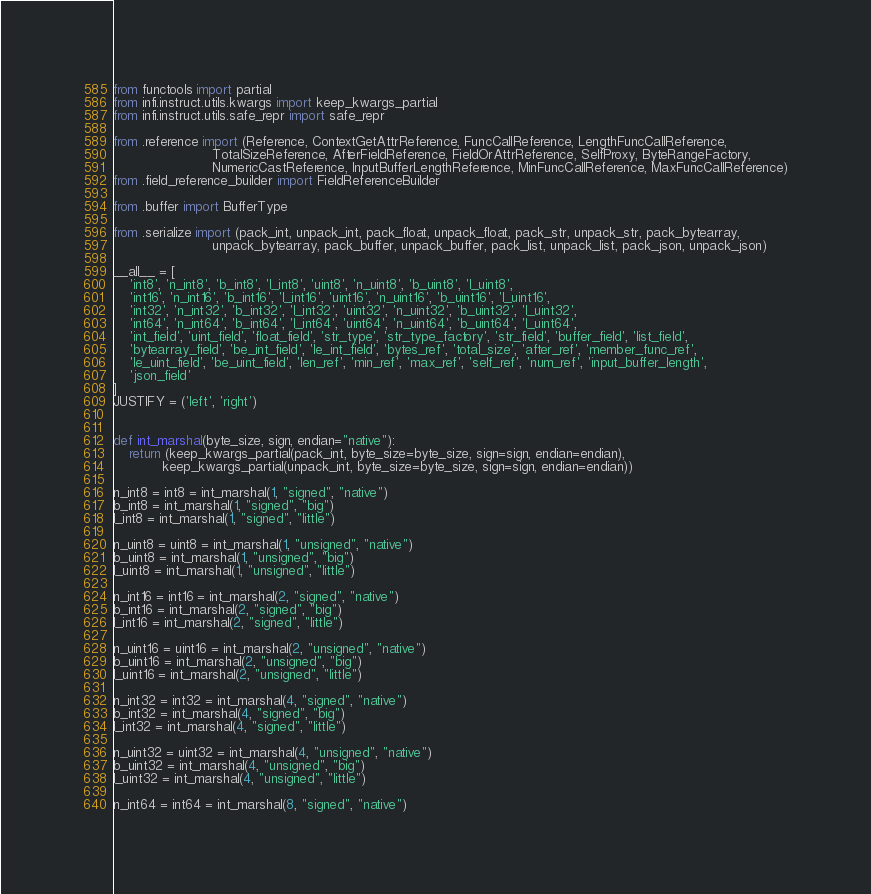<code> <loc_0><loc_0><loc_500><loc_500><_Python_>from functools import partial
from infi.instruct.utils.kwargs import keep_kwargs_partial
from infi.instruct.utils.safe_repr import safe_repr

from .reference import (Reference, ContextGetAttrReference, FuncCallReference, LengthFuncCallReference,
                        TotalSizeReference, AfterFieldReference, FieldOrAttrReference, SelfProxy, ByteRangeFactory,
                        NumericCastReference, InputBufferLengthReference, MinFuncCallReference, MaxFuncCallReference)
from .field_reference_builder import FieldReferenceBuilder

from .buffer import BufferType

from .serialize import (pack_int, unpack_int, pack_float, unpack_float, pack_str, unpack_str, pack_bytearray,
                        unpack_bytearray, pack_buffer, unpack_buffer, pack_list, unpack_list, pack_json, unpack_json)

__all__ = [
    'int8', 'n_int8', 'b_int8', 'l_int8', 'uint8', 'n_uint8', 'b_uint8', 'l_uint8',
    'int16', 'n_int16', 'b_int16', 'l_int16', 'uint16', 'n_uint16', 'b_uint16', 'l_uint16',
    'int32', 'n_int32', 'b_int32', 'l_int32', 'uint32', 'n_uint32', 'b_uint32', 'l_uint32',
    'int64', 'n_int64', 'b_int64', 'l_int64', 'uint64', 'n_uint64', 'b_uint64', 'l_uint64',
    'int_field', 'uint_field', 'float_field', 'str_type', 'str_type_factory', 'str_field', 'buffer_field', 'list_field',
    'bytearray_field', 'be_int_field', 'le_int_field', 'bytes_ref', 'total_size', 'after_ref', 'member_func_ref',
    'le_uint_field', 'be_uint_field', 'len_ref', 'min_ref', 'max_ref', 'self_ref', 'num_ref', 'input_buffer_length',
    'json_field'
]
JUSTIFY = ('left', 'right')


def int_marshal(byte_size, sign, endian="native"):
    return (keep_kwargs_partial(pack_int, byte_size=byte_size, sign=sign, endian=endian),
            keep_kwargs_partial(unpack_int, byte_size=byte_size, sign=sign, endian=endian))

n_int8 = int8 = int_marshal(1, "signed", "native")
b_int8 = int_marshal(1, "signed", "big")
l_int8 = int_marshal(1, "signed", "little")

n_uint8 = uint8 = int_marshal(1, "unsigned", "native")
b_uint8 = int_marshal(1, "unsigned", "big")
l_uint8 = int_marshal(1, "unsigned", "little")

n_int16 = int16 = int_marshal(2, "signed", "native")
b_int16 = int_marshal(2, "signed", "big")
l_int16 = int_marshal(2, "signed", "little")

n_uint16 = uint16 = int_marshal(2, "unsigned", "native")
b_uint16 = int_marshal(2, "unsigned", "big")
l_uint16 = int_marshal(2, "unsigned", "little")

n_int32 = int32 = int_marshal(4, "signed", "native")
b_int32 = int_marshal(4, "signed", "big")
l_int32 = int_marshal(4, "signed", "little")

n_uint32 = uint32 = int_marshal(4, "unsigned", "native")
b_uint32 = int_marshal(4, "unsigned", "big")
l_uint32 = int_marshal(4, "unsigned", "little")

n_int64 = int64 = int_marshal(8, "signed", "native")</code> 